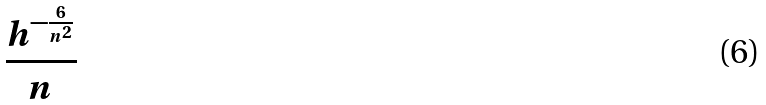Convert formula to latex. <formula><loc_0><loc_0><loc_500><loc_500>\frac { h ^ { - \frac { 6 } { n ^ { 2 } } } } { n }</formula> 